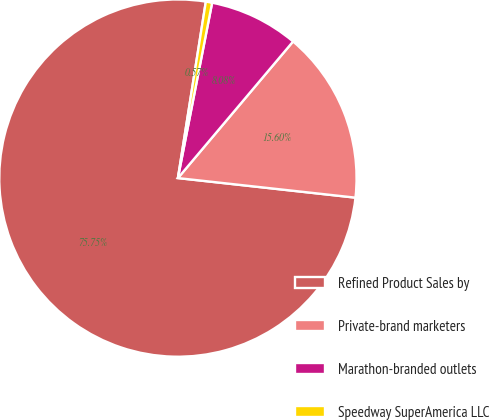Convert chart. <chart><loc_0><loc_0><loc_500><loc_500><pie_chart><fcel>Refined Product Sales by<fcel>Private-brand marketers<fcel>Marathon-branded outlets<fcel>Speedway SuperAmerica LLC<nl><fcel>75.75%<fcel>15.6%<fcel>8.08%<fcel>0.57%<nl></chart> 